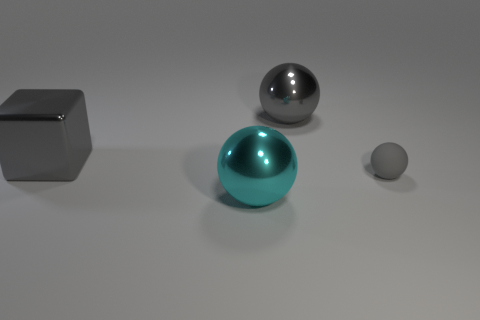Subtract all cyan metal balls. How many balls are left? 2 Subtract all cyan blocks. How many gray spheres are left? 2 Add 3 big metallic objects. How many objects exist? 7 Subtract all big purple shiny objects. Subtract all gray spheres. How many objects are left? 2 Add 4 big spheres. How many big spheres are left? 6 Add 3 small blue metallic cubes. How many small blue metallic cubes exist? 3 Subtract all gray spheres. How many spheres are left? 1 Subtract 0 blue cylinders. How many objects are left? 4 Subtract all cubes. How many objects are left? 3 Subtract 2 balls. How many balls are left? 1 